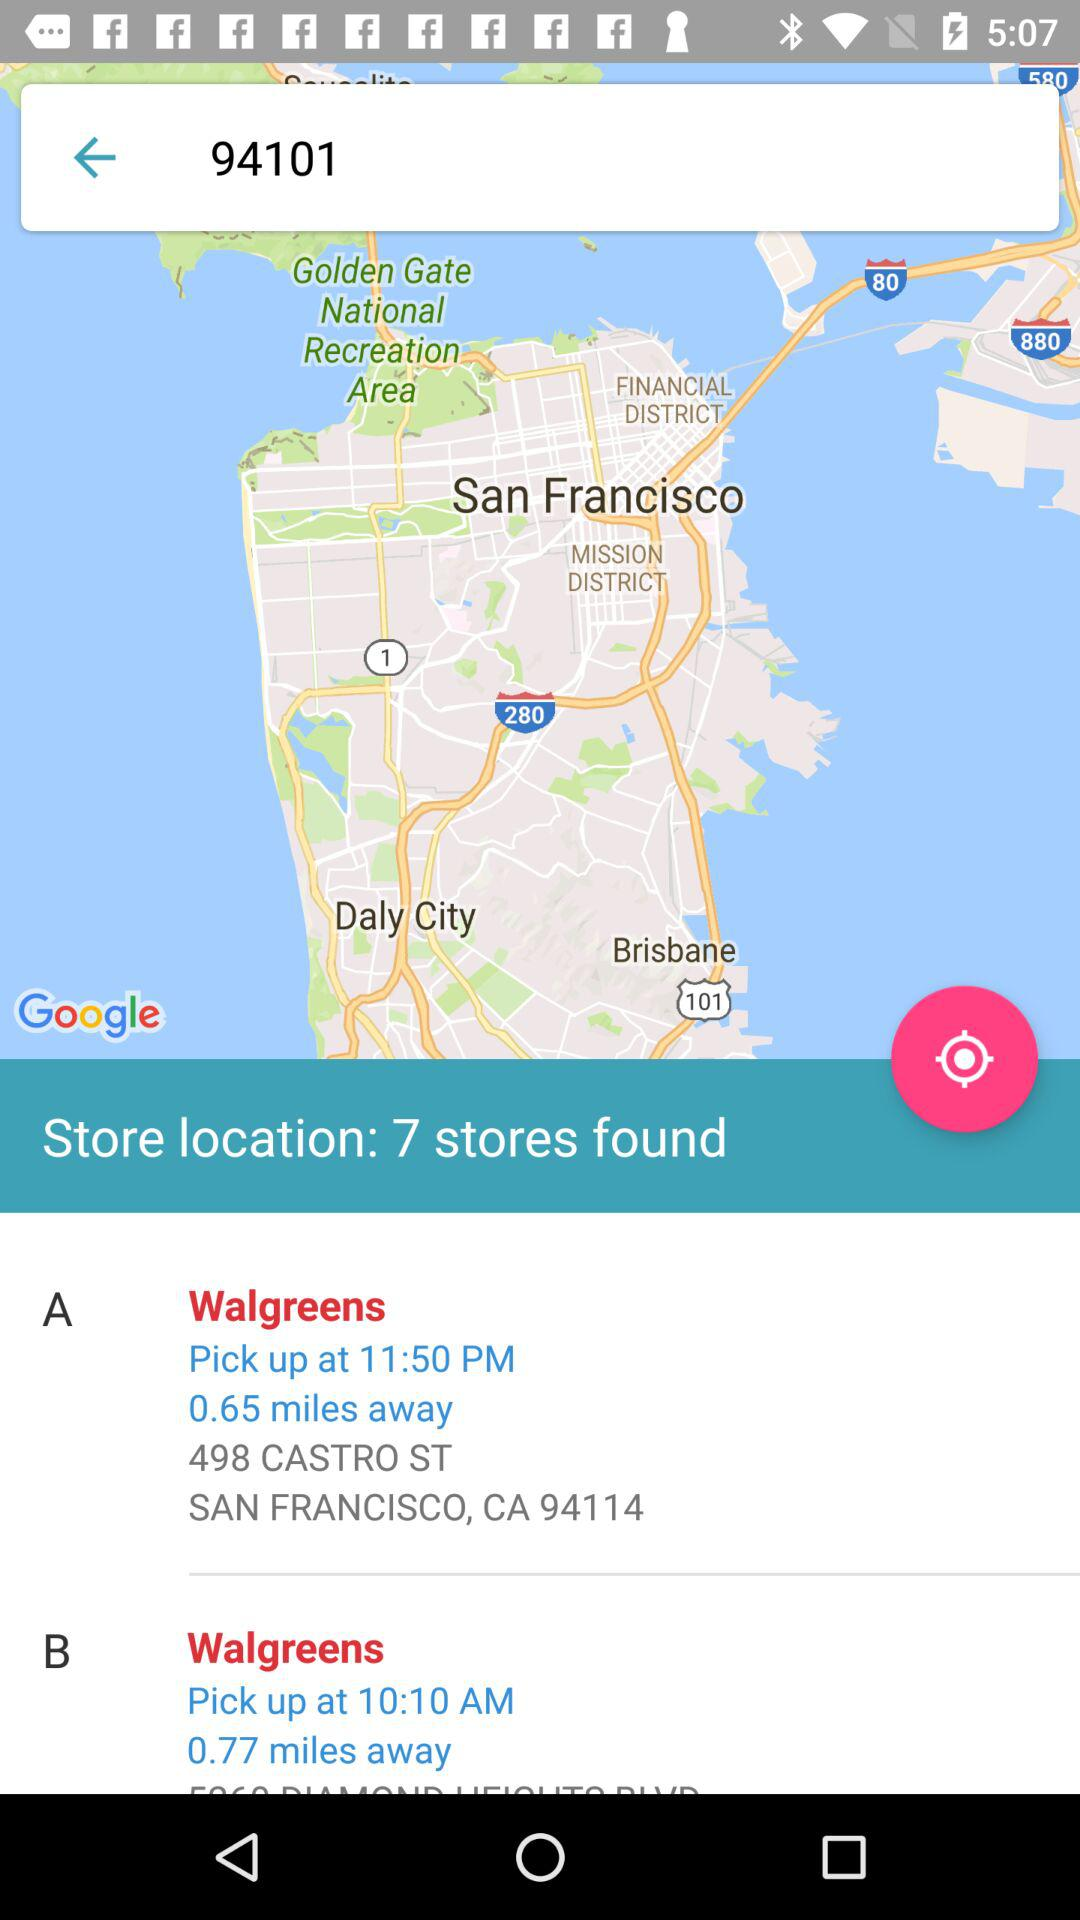For what zipcode is the person searching? The zip code is 94101. 